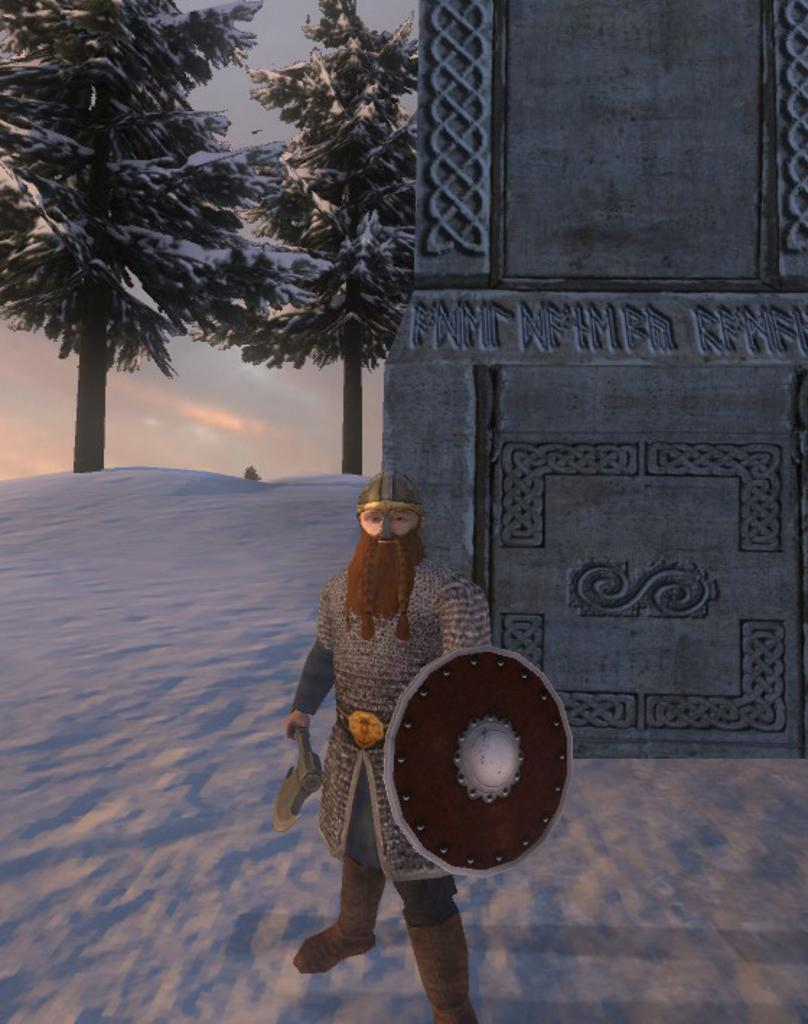Who is present in the image? There is a man in the image. What structure can be seen on the right side of the image? There appears to be a fort on the right side of the image. What type of weather is depicted in the image? There is snow on the left side of the image. What can be seen in the background of the image? There are trees and the sky visible in the background of the image. What type of feather can be seen falling from the sky in the image? There is no feather falling from the sky in the image. How many roses are present in the image? There are no roses present in the image. 